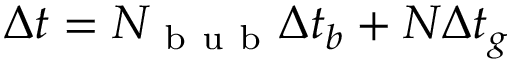<formula> <loc_0><loc_0><loc_500><loc_500>\Delta t = N _ { b u b } \Delta t _ { b } + N \Delta t _ { g }</formula> 